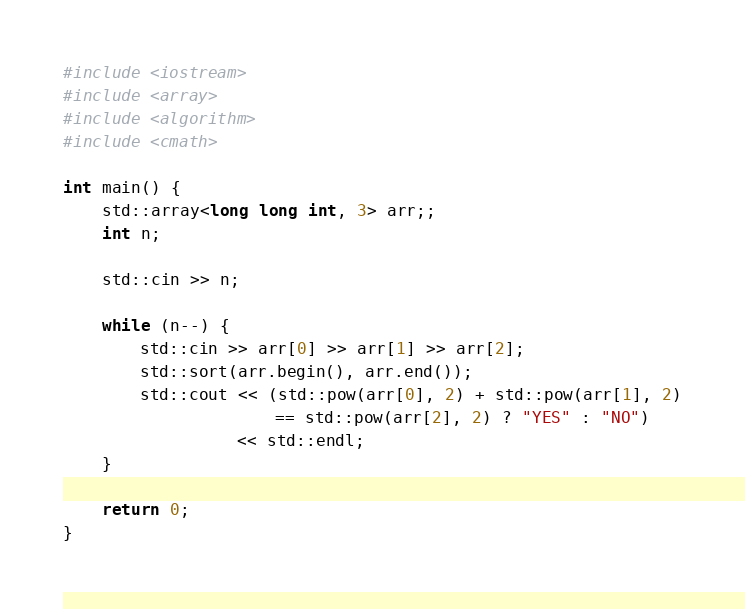Convert code to text. <code><loc_0><loc_0><loc_500><loc_500><_C++_>#include <iostream>
#include <array>
#include <algorithm>
#include <cmath>

int main() {
    std::array<long long int, 3> arr;;
    int n;
    
    std::cin >> n;

    while (n--) {
        std::cin >> arr[0] >> arr[1] >> arr[2];
        std::sort(arr.begin(), arr.end());
        std::cout << (std::pow(arr[0], 2) + std::pow(arr[1], 2)
                      == std::pow(arr[2], 2) ? "YES" : "NO")
                  << std::endl;
    }

    return 0;
}</code> 